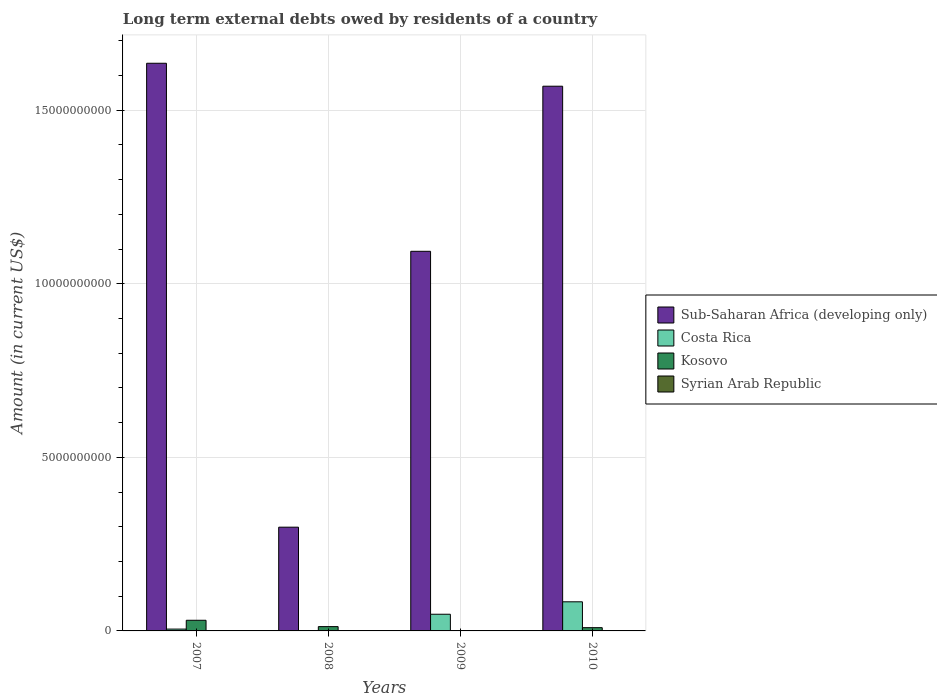How many different coloured bars are there?
Your answer should be very brief. 3. How many groups of bars are there?
Give a very brief answer. 4. Are the number of bars on each tick of the X-axis equal?
Offer a very short reply. No. How many bars are there on the 2nd tick from the right?
Provide a succinct answer. 2. What is the label of the 1st group of bars from the left?
Your answer should be compact. 2007. In how many cases, is the number of bars for a given year not equal to the number of legend labels?
Offer a very short reply. 4. What is the amount of long-term external debts owed by residents in Costa Rica in 2009?
Ensure brevity in your answer.  4.81e+08. Across all years, what is the maximum amount of long-term external debts owed by residents in Kosovo?
Keep it short and to the point. 3.07e+08. Across all years, what is the minimum amount of long-term external debts owed by residents in Kosovo?
Your answer should be very brief. 0. What is the total amount of long-term external debts owed by residents in Kosovo in the graph?
Provide a short and direct response. 5.24e+08. What is the difference between the amount of long-term external debts owed by residents in Sub-Saharan Africa (developing only) in 2007 and that in 2010?
Keep it short and to the point. 6.61e+08. What is the difference between the amount of long-term external debts owed by residents in Sub-Saharan Africa (developing only) in 2007 and the amount of long-term external debts owed by residents in Syrian Arab Republic in 2008?
Your response must be concise. 1.64e+1. What is the average amount of long-term external debts owed by residents in Kosovo per year?
Give a very brief answer. 1.31e+08. In the year 2007, what is the difference between the amount of long-term external debts owed by residents in Kosovo and amount of long-term external debts owed by residents in Sub-Saharan Africa (developing only)?
Make the answer very short. -1.60e+1. What is the ratio of the amount of long-term external debts owed by residents in Kosovo in 2007 to that in 2010?
Give a very brief answer. 3.26. Is the amount of long-term external debts owed by residents in Kosovo in 2007 less than that in 2010?
Your answer should be very brief. No. What is the difference between the highest and the second highest amount of long-term external debts owed by residents in Kosovo?
Provide a short and direct response. 1.83e+08. What is the difference between the highest and the lowest amount of long-term external debts owed by residents in Kosovo?
Your response must be concise. 3.07e+08. How many bars are there?
Your answer should be compact. 10. Are all the bars in the graph horizontal?
Offer a very short reply. No. How many years are there in the graph?
Give a very brief answer. 4. What is the difference between two consecutive major ticks on the Y-axis?
Provide a succinct answer. 5.00e+09. Are the values on the major ticks of Y-axis written in scientific E-notation?
Ensure brevity in your answer.  No. Does the graph contain any zero values?
Your answer should be compact. Yes. Does the graph contain grids?
Make the answer very short. Yes. How are the legend labels stacked?
Offer a terse response. Vertical. What is the title of the graph?
Ensure brevity in your answer.  Long term external debts owed by residents of a country. What is the label or title of the X-axis?
Your response must be concise. Years. What is the label or title of the Y-axis?
Keep it short and to the point. Amount (in current US$). What is the Amount (in current US$) in Sub-Saharan Africa (developing only) in 2007?
Ensure brevity in your answer.  1.64e+1. What is the Amount (in current US$) in Costa Rica in 2007?
Offer a very short reply. 5.27e+07. What is the Amount (in current US$) of Kosovo in 2007?
Provide a short and direct response. 3.07e+08. What is the Amount (in current US$) of Sub-Saharan Africa (developing only) in 2008?
Make the answer very short. 2.99e+09. What is the Amount (in current US$) of Kosovo in 2008?
Offer a very short reply. 1.24e+08. What is the Amount (in current US$) of Sub-Saharan Africa (developing only) in 2009?
Your response must be concise. 1.09e+1. What is the Amount (in current US$) in Costa Rica in 2009?
Offer a terse response. 4.81e+08. What is the Amount (in current US$) in Sub-Saharan Africa (developing only) in 2010?
Your answer should be compact. 1.57e+1. What is the Amount (in current US$) in Costa Rica in 2010?
Your answer should be very brief. 8.39e+08. What is the Amount (in current US$) of Kosovo in 2010?
Offer a terse response. 9.39e+07. Across all years, what is the maximum Amount (in current US$) in Sub-Saharan Africa (developing only)?
Ensure brevity in your answer.  1.64e+1. Across all years, what is the maximum Amount (in current US$) of Costa Rica?
Provide a short and direct response. 8.39e+08. Across all years, what is the maximum Amount (in current US$) of Kosovo?
Offer a very short reply. 3.07e+08. Across all years, what is the minimum Amount (in current US$) of Sub-Saharan Africa (developing only)?
Provide a succinct answer. 2.99e+09. Across all years, what is the minimum Amount (in current US$) of Costa Rica?
Offer a very short reply. 0. Across all years, what is the minimum Amount (in current US$) in Kosovo?
Provide a succinct answer. 0. What is the total Amount (in current US$) in Sub-Saharan Africa (developing only) in the graph?
Provide a succinct answer. 4.60e+1. What is the total Amount (in current US$) of Costa Rica in the graph?
Offer a terse response. 1.37e+09. What is the total Amount (in current US$) of Kosovo in the graph?
Your answer should be very brief. 5.24e+08. What is the difference between the Amount (in current US$) of Sub-Saharan Africa (developing only) in 2007 and that in 2008?
Keep it short and to the point. 1.34e+1. What is the difference between the Amount (in current US$) of Kosovo in 2007 and that in 2008?
Your response must be concise. 1.83e+08. What is the difference between the Amount (in current US$) of Sub-Saharan Africa (developing only) in 2007 and that in 2009?
Your answer should be compact. 5.42e+09. What is the difference between the Amount (in current US$) in Costa Rica in 2007 and that in 2009?
Ensure brevity in your answer.  -4.28e+08. What is the difference between the Amount (in current US$) in Sub-Saharan Africa (developing only) in 2007 and that in 2010?
Make the answer very short. 6.61e+08. What is the difference between the Amount (in current US$) of Costa Rica in 2007 and that in 2010?
Provide a succinct answer. -7.86e+08. What is the difference between the Amount (in current US$) in Kosovo in 2007 and that in 2010?
Your answer should be very brief. 2.13e+08. What is the difference between the Amount (in current US$) in Sub-Saharan Africa (developing only) in 2008 and that in 2009?
Give a very brief answer. -7.95e+09. What is the difference between the Amount (in current US$) in Sub-Saharan Africa (developing only) in 2008 and that in 2010?
Provide a short and direct response. -1.27e+1. What is the difference between the Amount (in current US$) in Kosovo in 2008 and that in 2010?
Your answer should be very brief. 2.99e+07. What is the difference between the Amount (in current US$) in Sub-Saharan Africa (developing only) in 2009 and that in 2010?
Your answer should be compact. -4.76e+09. What is the difference between the Amount (in current US$) of Costa Rica in 2009 and that in 2010?
Ensure brevity in your answer.  -3.58e+08. What is the difference between the Amount (in current US$) of Sub-Saharan Africa (developing only) in 2007 and the Amount (in current US$) of Kosovo in 2008?
Provide a short and direct response. 1.62e+1. What is the difference between the Amount (in current US$) in Costa Rica in 2007 and the Amount (in current US$) in Kosovo in 2008?
Make the answer very short. -7.10e+07. What is the difference between the Amount (in current US$) of Sub-Saharan Africa (developing only) in 2007 and the Amount (in current US$) of Costa Rica in 2009?
Provide a short and direct response. 1.59e+1. What is the difference between the Amount (in current US$) in Sub-Saharan Africa (developing only) in 2007 and the Amount (in current US$) in Costa Rica in 2010?
Your response must be concise. 1.55e+1. What is the difference between the Amount (in current US$) in Sub-Saharan Africa (developing only) in 2007 and the Amount (in current US$) in Kosovo in 2010?
Provide a short and direct response. 1.63e+1. What is the difference between the Amount (in current US$) of Costa Rica in 2007 and the Amount (in current US$) of Kosovo in 2010?
Provide a short and direct response. -4.12e+07. What is the difference between the Amount (in current US$) in Sub-Saharan Africa (developing only) in 2008 and the Amount (in current US$) in Costa Rica in 2009?
Your answer should be compact. 2.51e+09. What is the difference between the Amount (in current US$) of Sub-Saharan Africa (developing only) in 2008 and the Amount (in current US$) of Costa Rica in 2010?
Your response must be concise. 2.15e+09. What is the difference between the Amount (in current US$) of Sub-Saharan Africa (developing only) in 2008 and the Amount (in current US$) of Kosovo in 2010?
Ensure brevity in your answer.  2.89e+09. What is the difference between the Amount (in current US$) of Sub-Saharan Africa (developing only) in 2009 and the Amount (in current US$) of Costa Rica in 2010?
Provide a short and direct response. 1.01e+1. What is the difference between the Amount (in current US$) of Sub-Saharan Africa (developing only) in 2009 and the Amount (in current US$) of Kosovo in 2010?
Ensure brevity in your answer.  1.08e+1. What is the difference between the Amount (in current US$) in Costa Rica in 2009 and the Amount (in current US$) in Kosovo in 2010?
Your answer should be very brief. 3.87e+08. What is the average Amount (in current US$) in Sub-Saharan Africa (developing only) per year?
Ensure brevity in your answer.  1.15e+1. What is the average Amount (in current US$) of Costa Rica per year?
Keep it short and to the point. 3.43e+08. What is the average Amount (in current US$) in Kosovo per year?
Ensure brevity in your answer.  1.31e+08. In the year 2007, what is the difference between the Amount (in current US$) in Sub-Saharan Africa (developing only) and Amount (in current US$) in Costa Rica?
Provide a succinct answer. 1.63e+1. In the year 2007, what is the difference between the Amount (in current US$) in Sub-Saharan Africa (developing only) and Amount (in current US$) in Kosovo?
Give a very brief answer. 1.60e+1. In the year 2007, what is the difference between the Amount (in current US$) in Costa Rica and Amount (in current US$) in Kosovo?
Offer a very short reply. -2.54e+08. In the year 2008, what is the difference between the Amount (in current US$) of Sub-Saharan Africa (developing only) and Amount (in current US$) of Kosovo?
Ensure brevity in your answer.  2.86e+09. In the year 2009, what is the difference between the Amount (in current US$) in Sub-Saharan Africa (developing only) and Amount (in current US$) in Costa Rica?
Provide a succinct answer. 1.05e+1. In the year 2010, what is the difference between the Amount (in current US$) in Sub-Saharan Africa (developing only) and Amount (in current US$) in Costa Rica?
Your answer should be compact. 1.49e+1. In the year 2010, what is the difference between the Amount (in current US$) of Sub-Saharan Africa (developing only) and Amount (in current US$) of Kosovo?
Give a very brief answer. 1.56e+1. In the year 2010, what is the difference between the Amount (in current US$) in Costa Rica and Amount (in current US$) in Kosovo?
Make the answer very short. 7.45e+08. What is the ratio of the Amount (in current US$) of Sub-Saharan Africa (developing only) in 2007 to that in 2008?
Provide a succinct answer. 5.47. What is the ratio of the Amount (in current US$) of Kosovo in 2007 to that in 2008?
Ensure brevity in your answer.  2.48. What is the ratio of the Amount (in current US$) in Sub-Saharan Africa (developing only) in 2007 to that in 2009?
Offer a very short reply. 1.5. What is the ratio of the Amount (in current US$) of Costa Rica in 2007 to that in 2009?
Offer a very short reply. 0.11. What is the ratio of the Amount (in current US$) of Sub-Saharan Africa (developing only) in 2007 to that in 2010?
Your response must be concise. 1.04. What is the ratio of the Amount (in current US$) in Costa Rica in 2007 to that in 2010?
Ensure brevity in your answer.  0.06. What is the ratio of the Amount (in current US$) of Kosovo in 2007 to that in 2010?
Provide a short and direct response. 3.26. What is the ratio of the Amount (in current US$) in Sub-Saharan Africa (developing only) in 2008 to that in 2009?
Your answer should be very brief. 0.27. What is the ratio of the Amount (in current US$) of Sub-Saharan Africa (developing only) in 2008 to that in 2010?
Your answer should be compact. 0.19. What is the ratio of the Amount (in current US$) of Kosovo in 2008 to that in 2010?
Your response must be concise. 1.32. What is the ratio of the Amount (in current US$) of Sub-Saharan Africa (developing only) in 2009 to that in 2010?
Ensure brevity in your answer.  0.7. What is the ratio of the Amount (in current US$) of Costa Rica in 2009 to that in 2010?
Offer a terse response. 0.57. What is the difference between the highest and the second highest Amount (in current US$) of Sub-Saharan Africa (developing only)?
Your answer should be compact. 6.61e+08. What is the difference between the highest and the second highest Amount (in current US$) in Costa Rica?
Your response must be concise. 3.58e+08. What is the difference between the highest and the second highest Amount (in current US$) in Kosovo?
Ensure brevity in your answer.  1.83e+08. What is the difference between the highest and the lowest Amount (in current US$) in Sub-Saharan Africa (developing only)?
Provide a succinct answer. 1.34e+1. What is the difference between the highest and the lowest Amount (in current US$) in Costa Rica?
Ensure brevity in your answer.  8.39e+08. What is the difference between the highest and the lowest Amount (in current US$) in Kosovo?
Provide a succinct answer. 3.07e+08. 